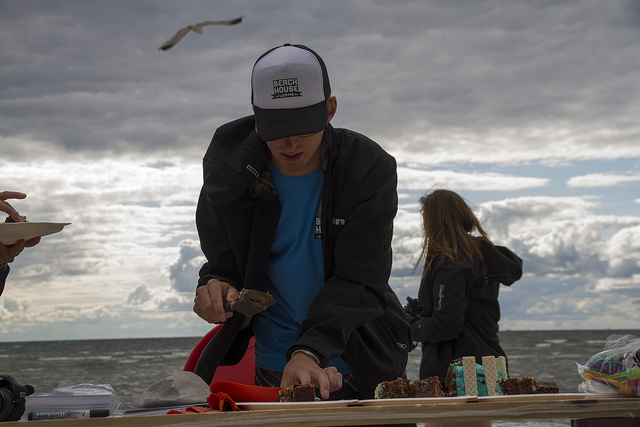Does the image suggest any specific event or activity taking place? While the specific details are not explicit, the presence of food being served and a person working attentively suggests that there might be a communal or social event occuring, perhaps a beach gathering, picnic, or a small outdoor celebration. What makes it look like a celebration? The presence of food on a serving table, especially what appears to be a cake, is often associated with celebratory events. That, combined with the outdoor setting, which might imply a relaxed and festive atmosphere, suggests that the gathering could be celebratory in nature. 